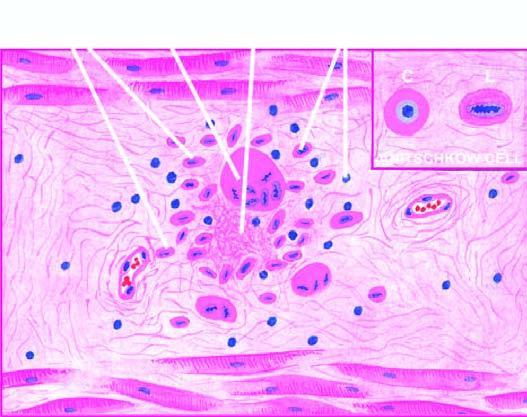does cross section cs show owl-eye appearance of central chromatin mass and perinuclear halo?
Answer the question using a single word or phrase. Yes 